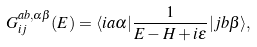<formula> <loc_0><loc_0><loc_500><loc_500>G _ { i j } ^ { a b , \alpha \beta } ( E ) = \langle i a \alpha | \frac { 1 } { E - H + i \epsilon } | j b \beta \rangle ,</formula> 